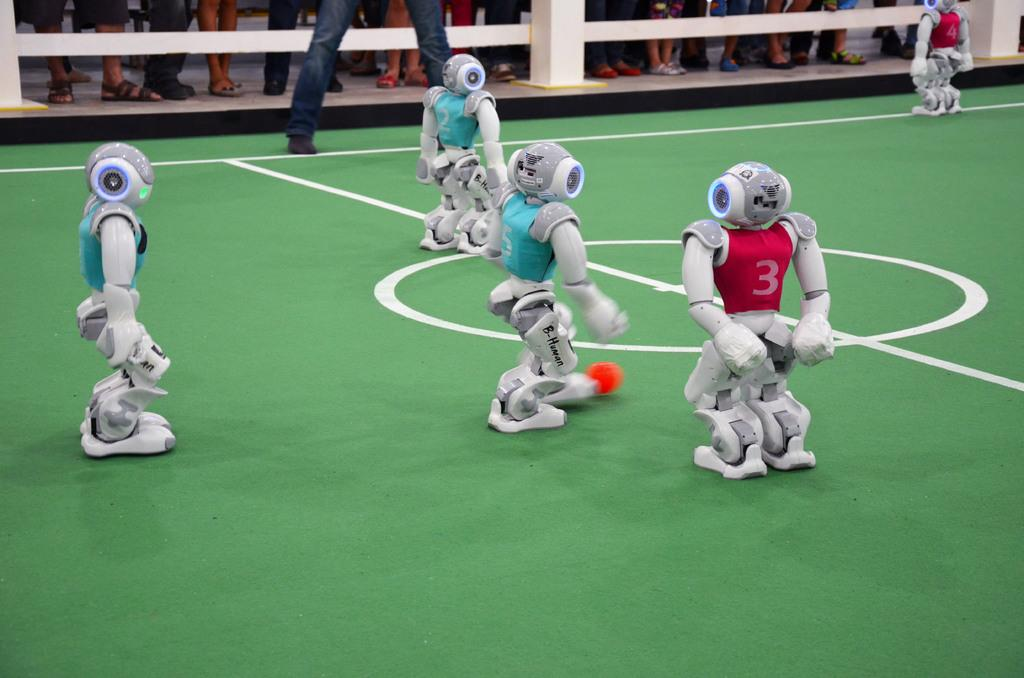<image>
Offer a succinct explanation of the picture presented. A robot labeled B-Human plays a game with other robots. 